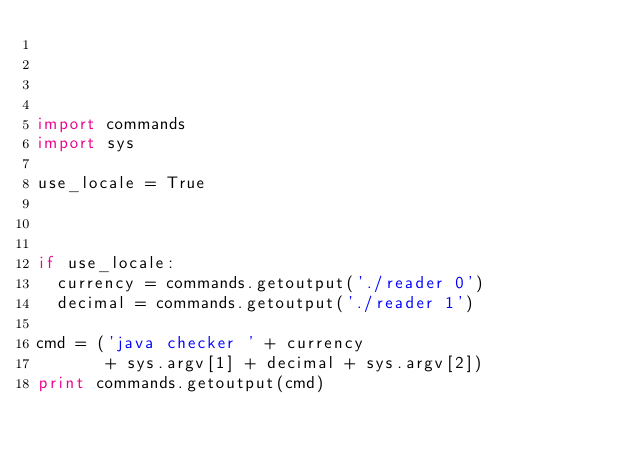<code> <loc_0><loc_0><loc_500><loc_500><_Python_>



import commands
import sys

use_locale = True



if use_locale:
  currency = commands.getoutput('./reader 0')
  decimal = commands.getoutput('./reader 1')

cmd = ('java checker ' + currency
       + sys.argv[1] + decimal + sys.argv[2])
print commands.getoutput(cmd)
</code> 